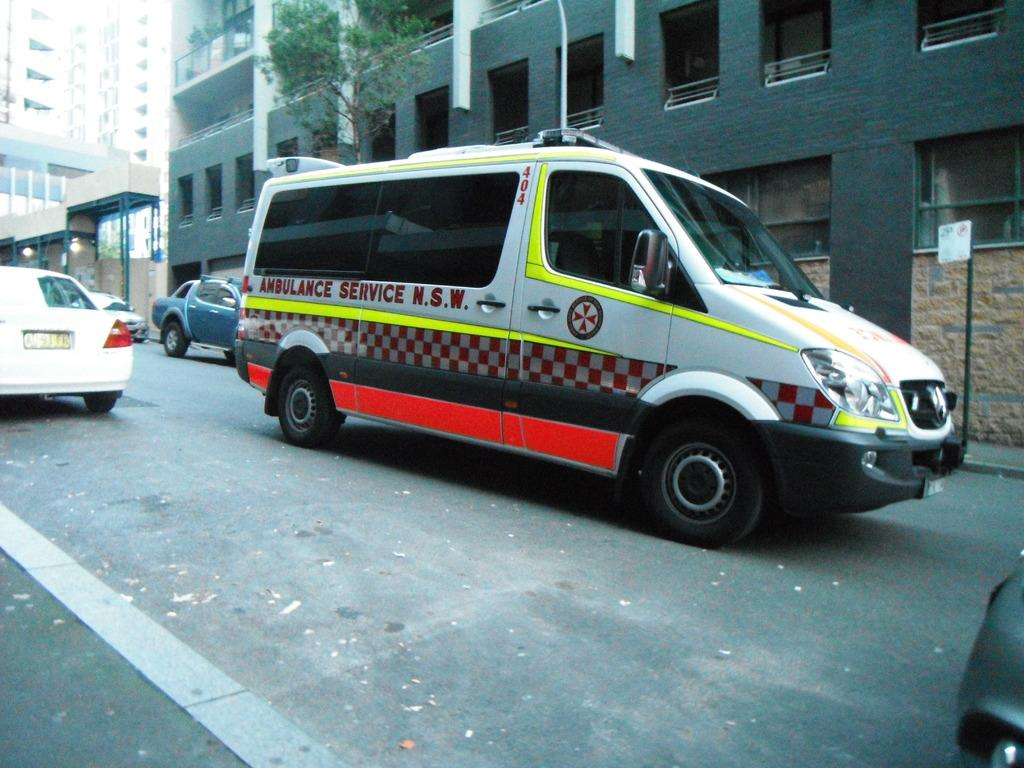<image>
Summarize the visual content of the image. A van with red and white checkers that says Ambulance Service down the side. 